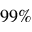<formula> <loc_0><loc_0><loc_500><loc_500>9 9 \%</formula> 